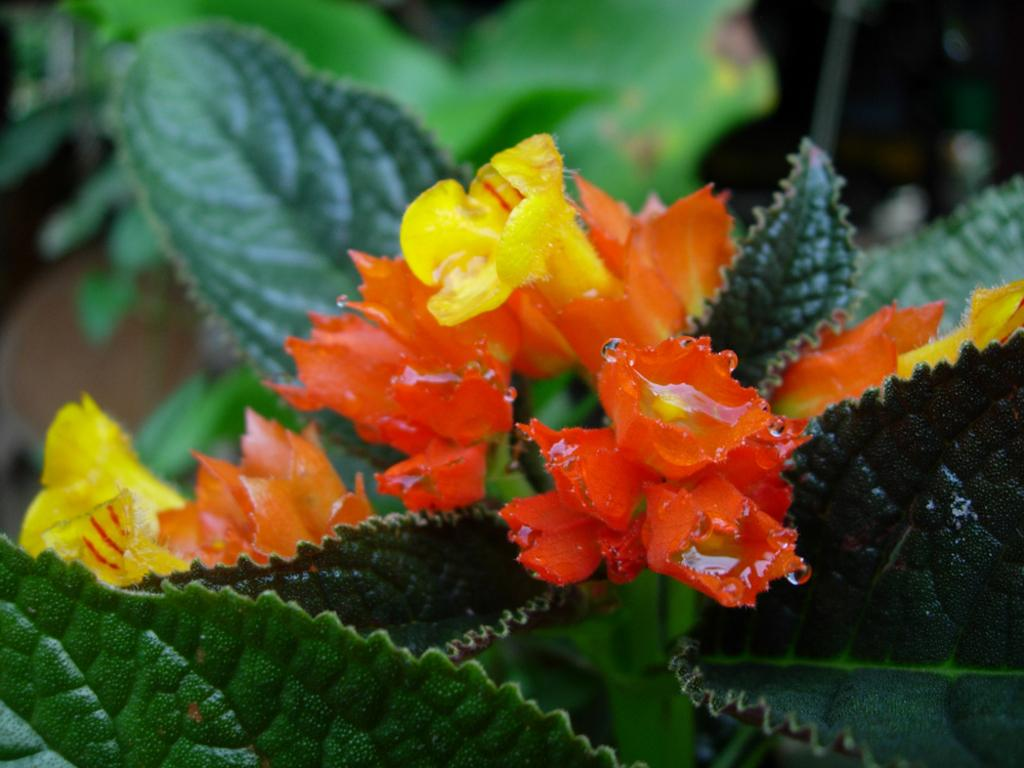What type of plants can be seen in the image? There are flowers and leaves in the image. Can you describe the background of the image? The background of the image is blurry. What historical event is depicted in the image involving giants? There is no historical event or giants depicted in the image; it features flowers and leaves with a blurry background. 